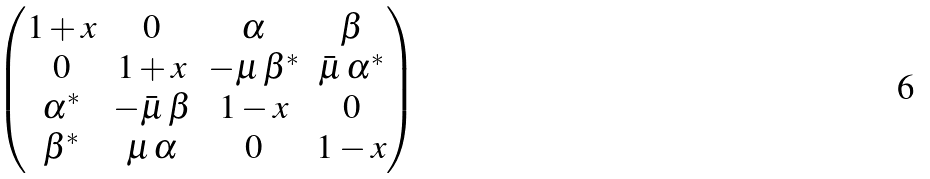Convert formula to latex. <formula><loc_0><loc_0><loc_500><loc_500>\begin{pmatrix} 1 + x & 0 & \alpha & \beta \\ 0 & 1 + x & - \mu \, \beta ^ { * } & \bar { \mu } \, \alpha ^ { * } \\ \alpha ^ { * } & - \bar { \mu } \, \beta & 1 - x & 0 \\ \beta ^ { * } & \mu \, \alpha & 0 & 1 - x \end{pmatrix}</formula> 